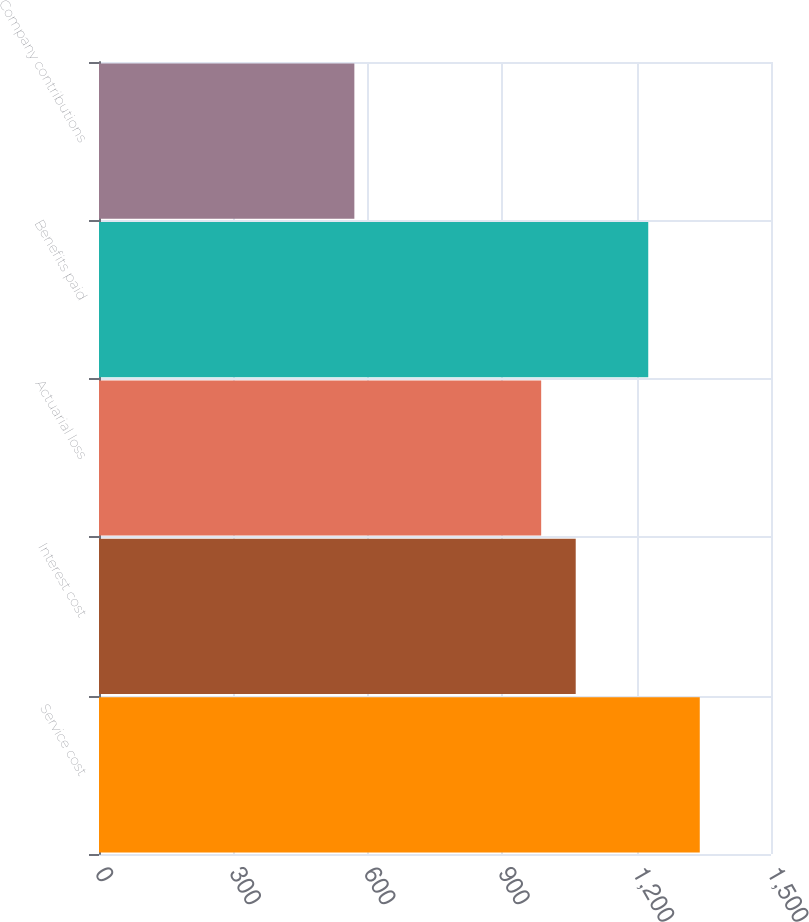Convert chart to OTSL. <chart><loc_0><loc_0><loc_500><loc_500><bar_chart><fcel>Service cost<fcel>Interest cost<fcel>Actuarial loss<fcel>Benefits paid<fcel>Company contributions<nl><fcel>1341<fcel>1064.1<fcel>987<fcel>1226<fcel>570<nl></chart> 